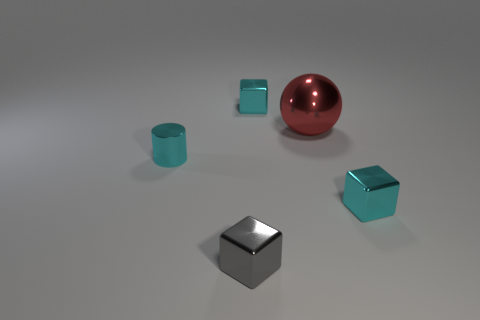What shape is the cyan shiny object right of the cube that is behind the cyan cube that is in front of the tiny metal cylinder?
Give a very brief answer. Cube. What number of objects are either brown shiny things or cyan metallic blocks that are behind the red sphere?
Offer a very short reply. 1. How big is the cyan metallic object that is in front of the tiny cylinder?
Keep it short and to the point. Small. Are the tiny gray object and the red sphere that is right of the cyan metal cylinder made of the same material?
Offer a terse response. Yes. There is a small block that is right of the cyan thing behind the small cyan cylinder; how many small gray metal blocks are behind it?
Provide a succinct answer. 0. What number of brown objects are either small shiny cylinders or large metallic balls?
Your answer should be very brief. 0. What is the shape of the cyan shiny thing that is behind the red sphere?
Offer a terse response. Cube. There is a shiny cylinder that is the same size as the gray thing; what is its color?
Your response must be concise. Cyan. Do the red thing and the tiny metal thing behind the cylinder have the same shape?
Your response must be concise. No. What material is the small cyan object that is on the left side of the tiny metallic cube that is in front of the tiny cyan shiny cube that is in front of the red metal sphere?
Your response must be concise. Metal. 